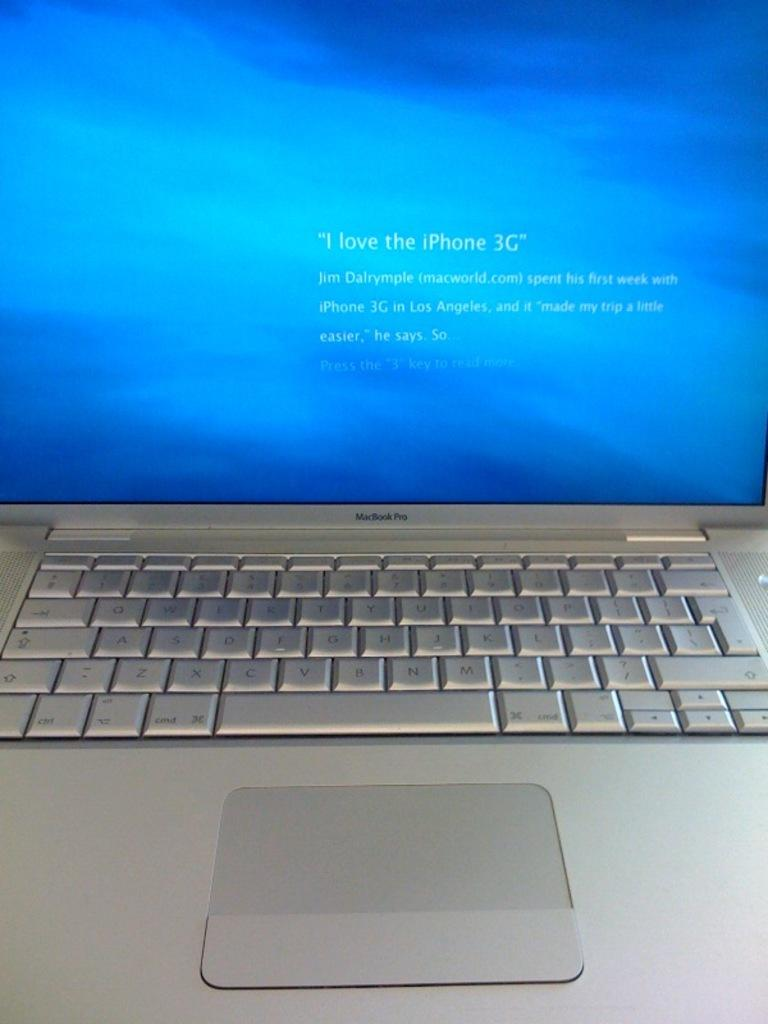<image>
Give a short and clear explanation of the subsequent image. A MacBook Pro displays a message on a blue background. 